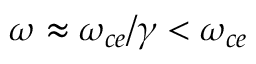Convert formula to latex. <formula><loc_0><loc_0><loc_500><loc_500>\omega \approx \omega _ { c e } / \gamma < \omega _ { c e }</formula> 